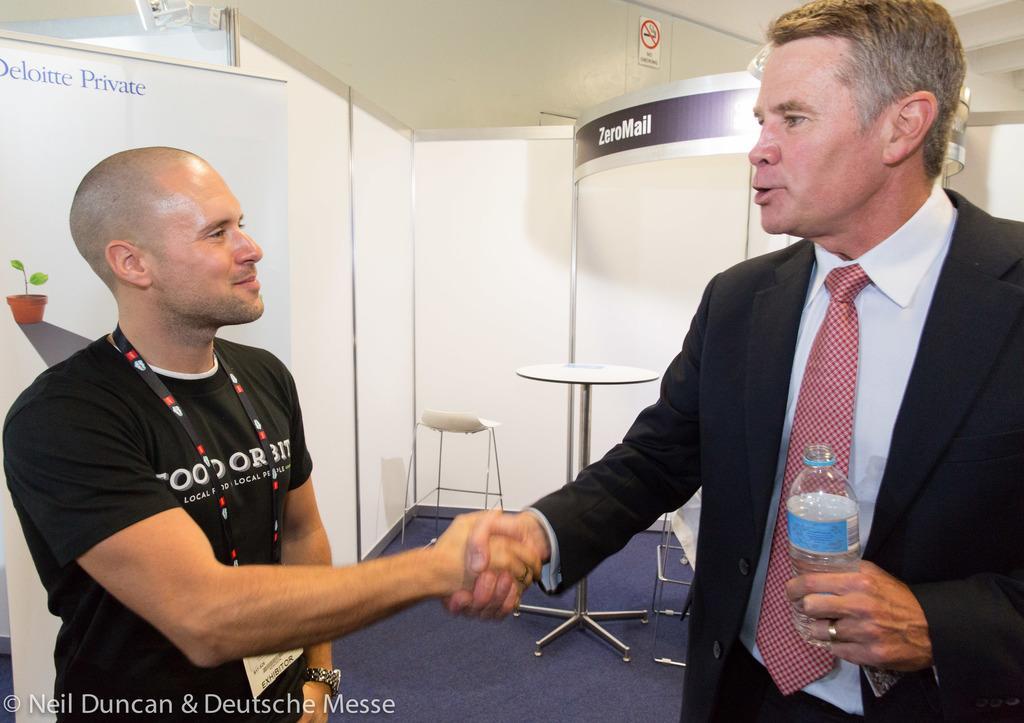Please provide a concise description of this image. These two persons are standing and holding hands each other and this person holding bottle,this person wear tag. On the background we can see wall,chair,table,poster,plant. This is floor. 